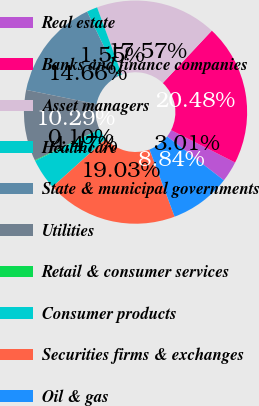Convert chart to OTSL. <chart><loc_0><loc_0><loc_500><loc_500><pie_chart><fcel>Real estate<fcel>Banks and finance companies<fcel>Asset managers<fcel>Healthcare<fcel>State & municipal governments<fcel>Utilities<fcel>Retail & consumer services<fcel>Consumer products<fcel>Securities firms & exchanges<fcel>Oil & gas<nl><fcel>3.01%<fcel>20.48%<fcel>17.57%<fcel>1.55%<fcel>14.66%<fcel>10.29%<fcel>0.1%<fcel>4.47%<fcel>19.03%<fcel>8.84%<nl></chart> 